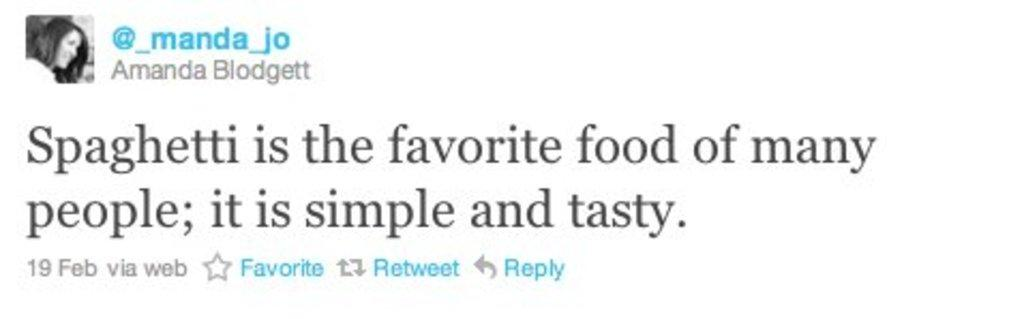What is the main subject of the image? There is a photo of a person in the image. Are there any words or phrases in the image? Yes, there is text in the image. What color is the background of the image? The background of the image is white. How many rabbits are visible in the image? There are no rabbits present in the image. What type of wrist accessory is the person wearing in the image? The image does not show the person's wrist or any accessories they might be wearing. 